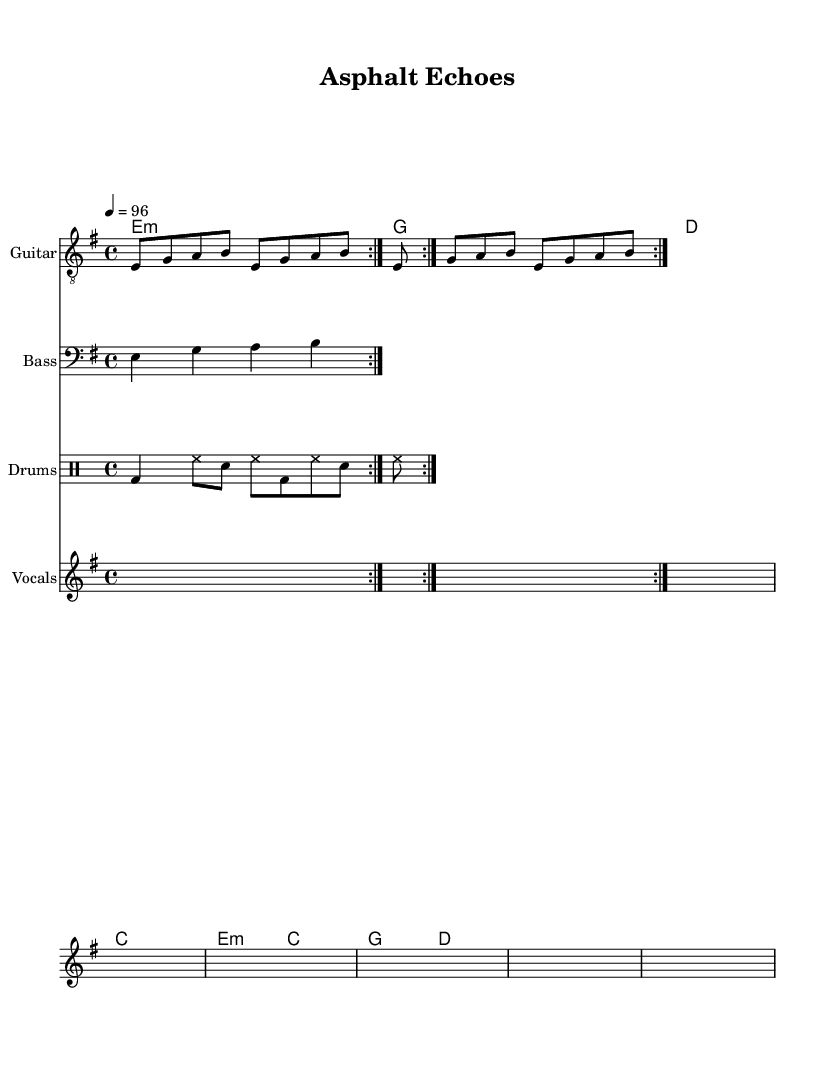What is the key signature of this music? The key signature indicated in the global section of the sheet music is E minor, which contains one sharp (F#).
Answer: E minor What is the time signature of this piece? The time signature noted in the global section is 4/4, which means there are four beats in a measure and a quarter note gets one beat.
Answer: 4/4 What is the tempo marking for the music? The tempo marking specified in the global section is 4 = 96, indicating the number of beats per minute to play the music.
Answer: 96 How many measures are in the verse? The verse is composed of four lines of lyrics and each line corresponds to one measure, meaning there are four measures total in the verse.
Answer: 4 Which instrument has the melodic riff in this score? The melodic riff is performed by the guitar, as indicated in the staff titled "Guitar." The guitar music section contains the repeating riff.
Answer: Guitar What is the text of the chorus section? The chorus lyrics are displayed in the lyrics section after the verse and start with "Asphalt echoes, day after day," capturing the essence of urban life and resistance.
Answer: Asphalt echoes, day after day What role does the bass play in this piece? The bass line supports the harmony and rhythm, providing a foundational sound to complement the guitar and drums, helping in driving the urban feel of the music.
Answer: Foundation 